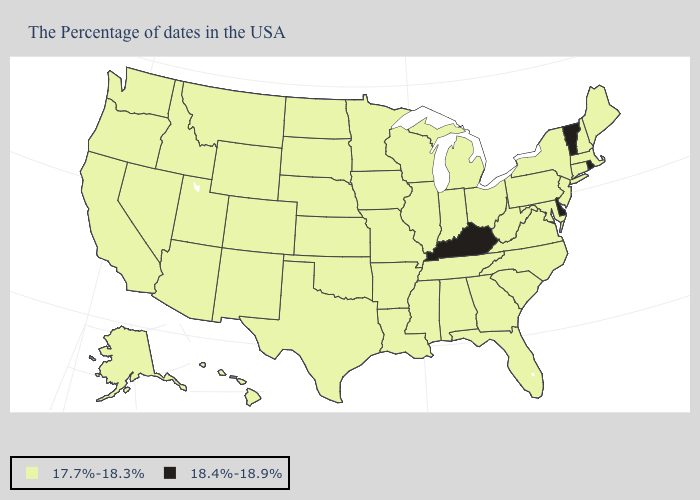What is the lowest value in states that border Maine?
Give a very brief answer. 17.7%-18.3%. Does Maryland have the lowest value in the USA?
Short answer required. Yes. Among the states that border Illinois , does Indiana have the lowest value?
Keep it brief. Yes. Which states have the highest value in the USA?
Write a very short answer. Rhode Island, Vermont, Delaware, Kentucky. What is the value of Massachusetts?
Short answer required. 17.7%-18.3%. What is the highest value in the Northeast ?
Keep it brief. 18.4%-18.9%. Which states hav the highest value in the West?
Short answer required. Wyoming, Colorado, New Mexico, Utah, Montana, Arizona, Idaho, Nevada, California, Washington, Oregon, Alaska, Hawaii. Which states have the highest value in the USA?
Answer briefly. Rhode Island, Vermont, Delaware, Kentucky. Does Iowa have a lower value than Vermont?
Give a very brief answer. Yes. What is the lowest value in states that border Nebraska?
Keep it brief. 17.7%-18.3%. Does the first symbol in the legend represent the smallest category?
Answer briefly. Yes. What is the lowest value in the USA?
Write a very short answer. 17.7%-18.3%. Name the states that have a value in the range 18.4%-18.9%?
Short answer required. Rhode Island, Vermont, Delaware, Kentucky. What is the highest value in the USA?
Write a very short answer. 18.4%-18.9%. 